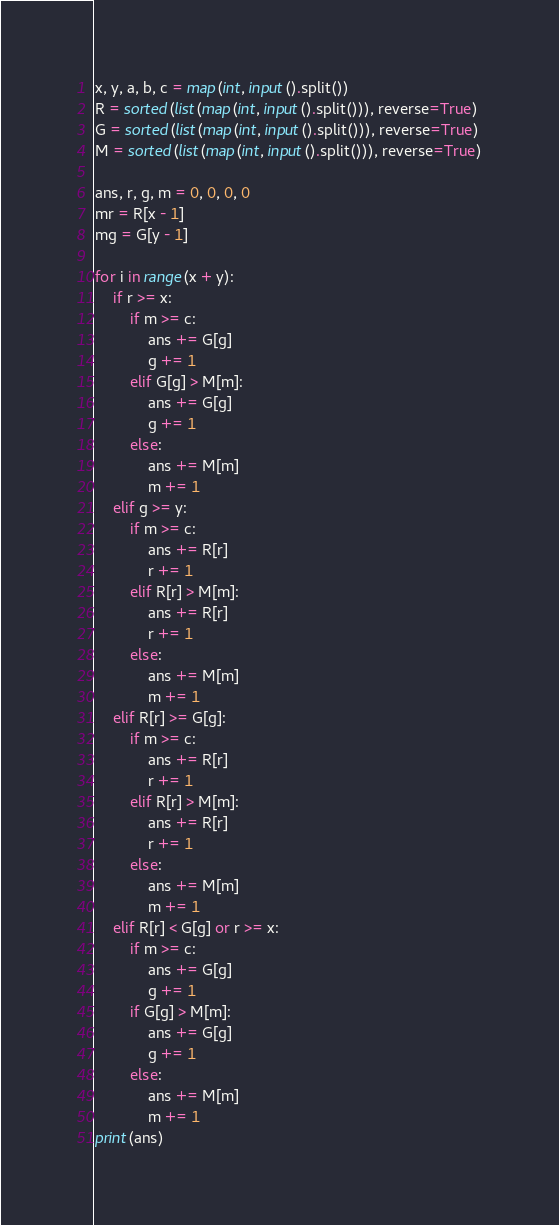<code> <loc_0><loc_0><loc_500><loc_500><_Python_>x, y, a, b, c = map(int, input().split())
R = sorted(list(map(int, input().split())), reverse=True)
G = sorted(list(map(int, input().split())), reverse=True)
M = sorted(list(map(int, input().split())), reverse=True)

ans, r, g, m = 0, 0, 0, 0
mr = R[x - 1]
mg = G[y - 1]

for i in range(x + y):
    if r >= x:
        if m >= c:
            ans += G[g]
            g += 1
        elif G[g] > M[m]:
            ans += G[g]
            g += 1
        else:
            ans += M[m]
            m += 1
    elif g >= y:
        if m >= c:
            ans += R[r]
            r += 1
        elif R[r] > M[m]:
            ans += R[r]
            r += 1
        else:
            ans += M[m]
            m += 1
    elif R[r] >= G[g]:
        if m >= c:
            ans += R[r]
            r += 1
        elif R[r] > M[m]:
            ans += R[r]
            r += 1
        else:
            ans += M[m]
            m += 1
    elif R[r] < G[g] or r >= x:
        if m >= c:
            ans += G[g]
            g += 1
        if G[g] > M[m]:
            ans += G[g]
            g += 1
        else:
            ans += M[m]
            m += 1
print(ans)
</code> 